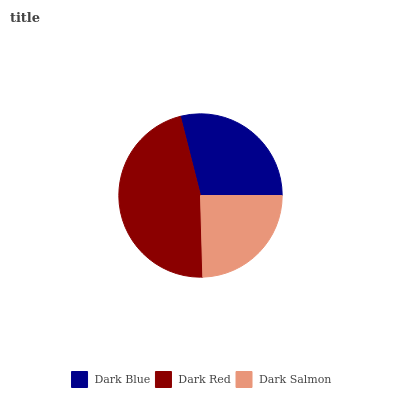Is Dark Salmon the minimum?
Answer yes or no. Yes. Is Dark Red the maximum?
Answer yes or no. Yes. Is Dark Red the minimum?
Answer yes or no. No. Is Dark Salmon the maximum?
Answer yes or no. No. Is Dark Red greater than Dark Salmon?
Answer yes or no. Yes. Is Dark Salmon less than Dark Red?
Answer yes or no. Yes. Is Dark Salmon greater than Dark Red?
Answer yes or no. No. Is Dark Red less than Dark Salmon?
Answer yes or no. No. Is Dark Blue the high median?
Answer yes or no. Yes. Is Dark Blue the low median?
Answer yes or no. Yes. Is Dark Red the high median?
Answer yes or no. No. Is Dark Red the low median?
Answer yes or no. No. 